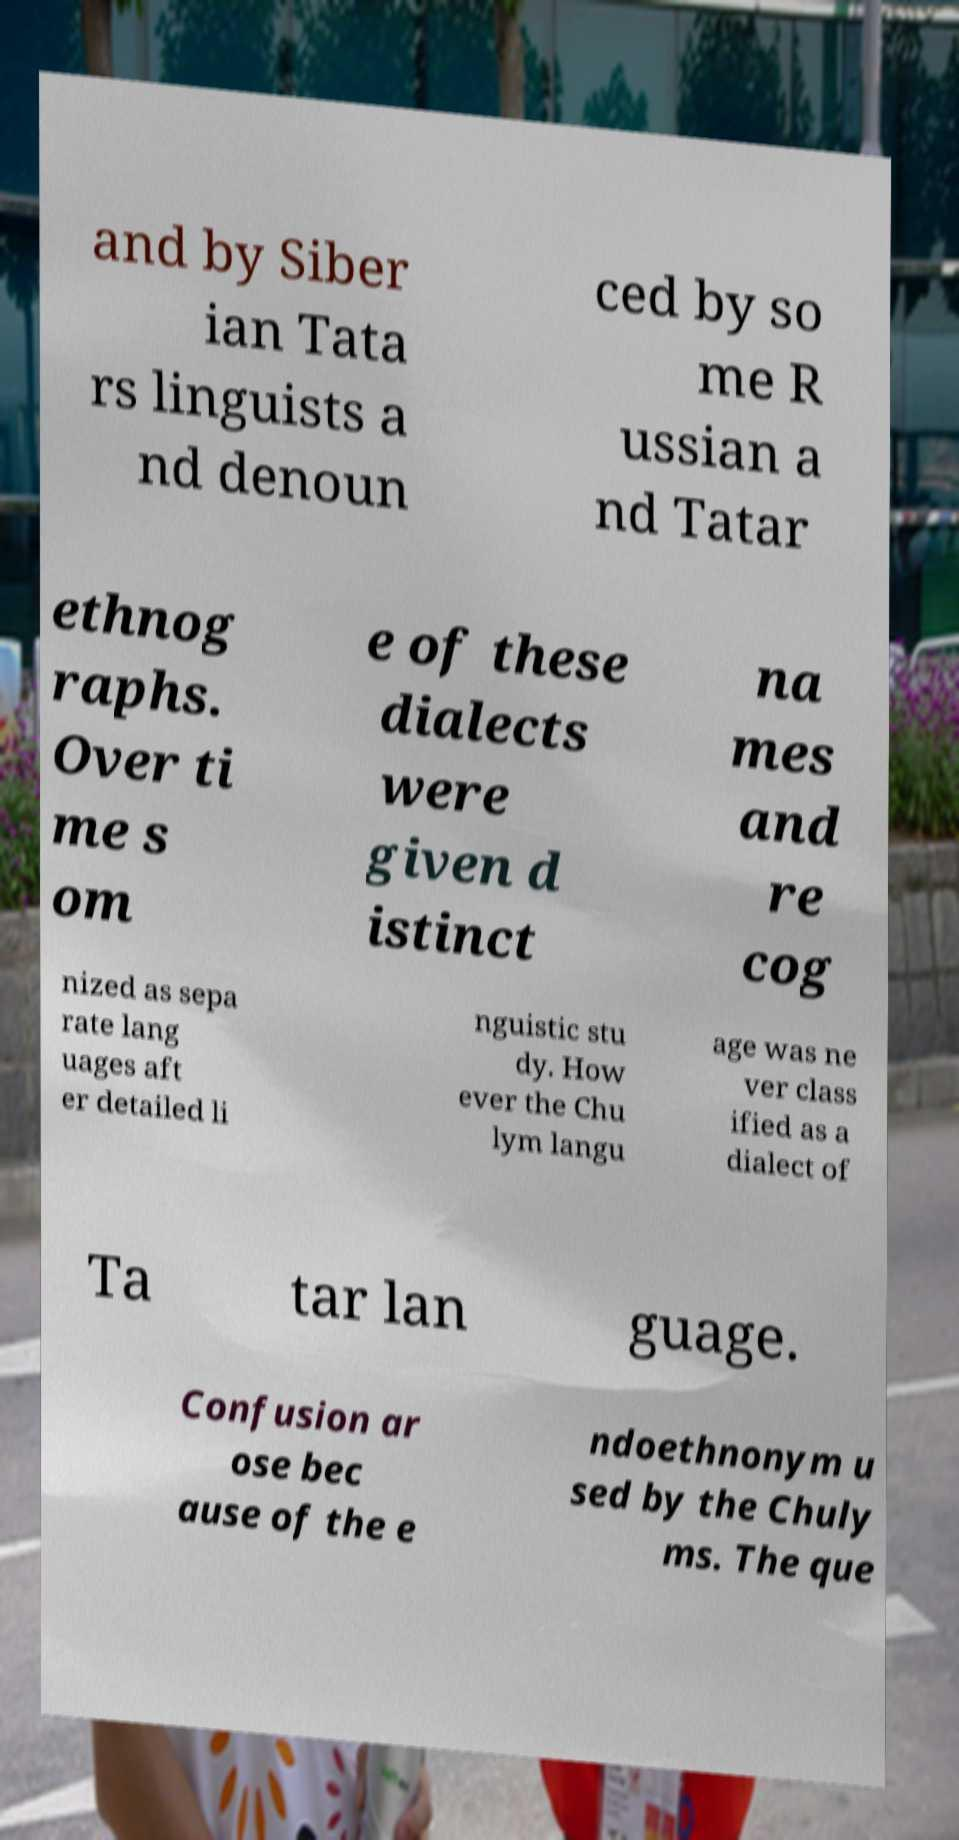Please read and relay the text visible in this image. What does it say? and by Siber ian Tata rs linguists a nd denoun ced by so me R ussian a nd Tatar ethnog raphs. Over ti me s om e of these dialects were given d istinct na mes and re cog nized as sepa rate lang uages aft er detailed li nguistic stu dy. How ever the Chu lym langu age was ne ver class ified as a dialect of Ta tar lan guage. Confusion ar ose bec ause of the e ndoethnonym u sed by the Chuly ms. The que 